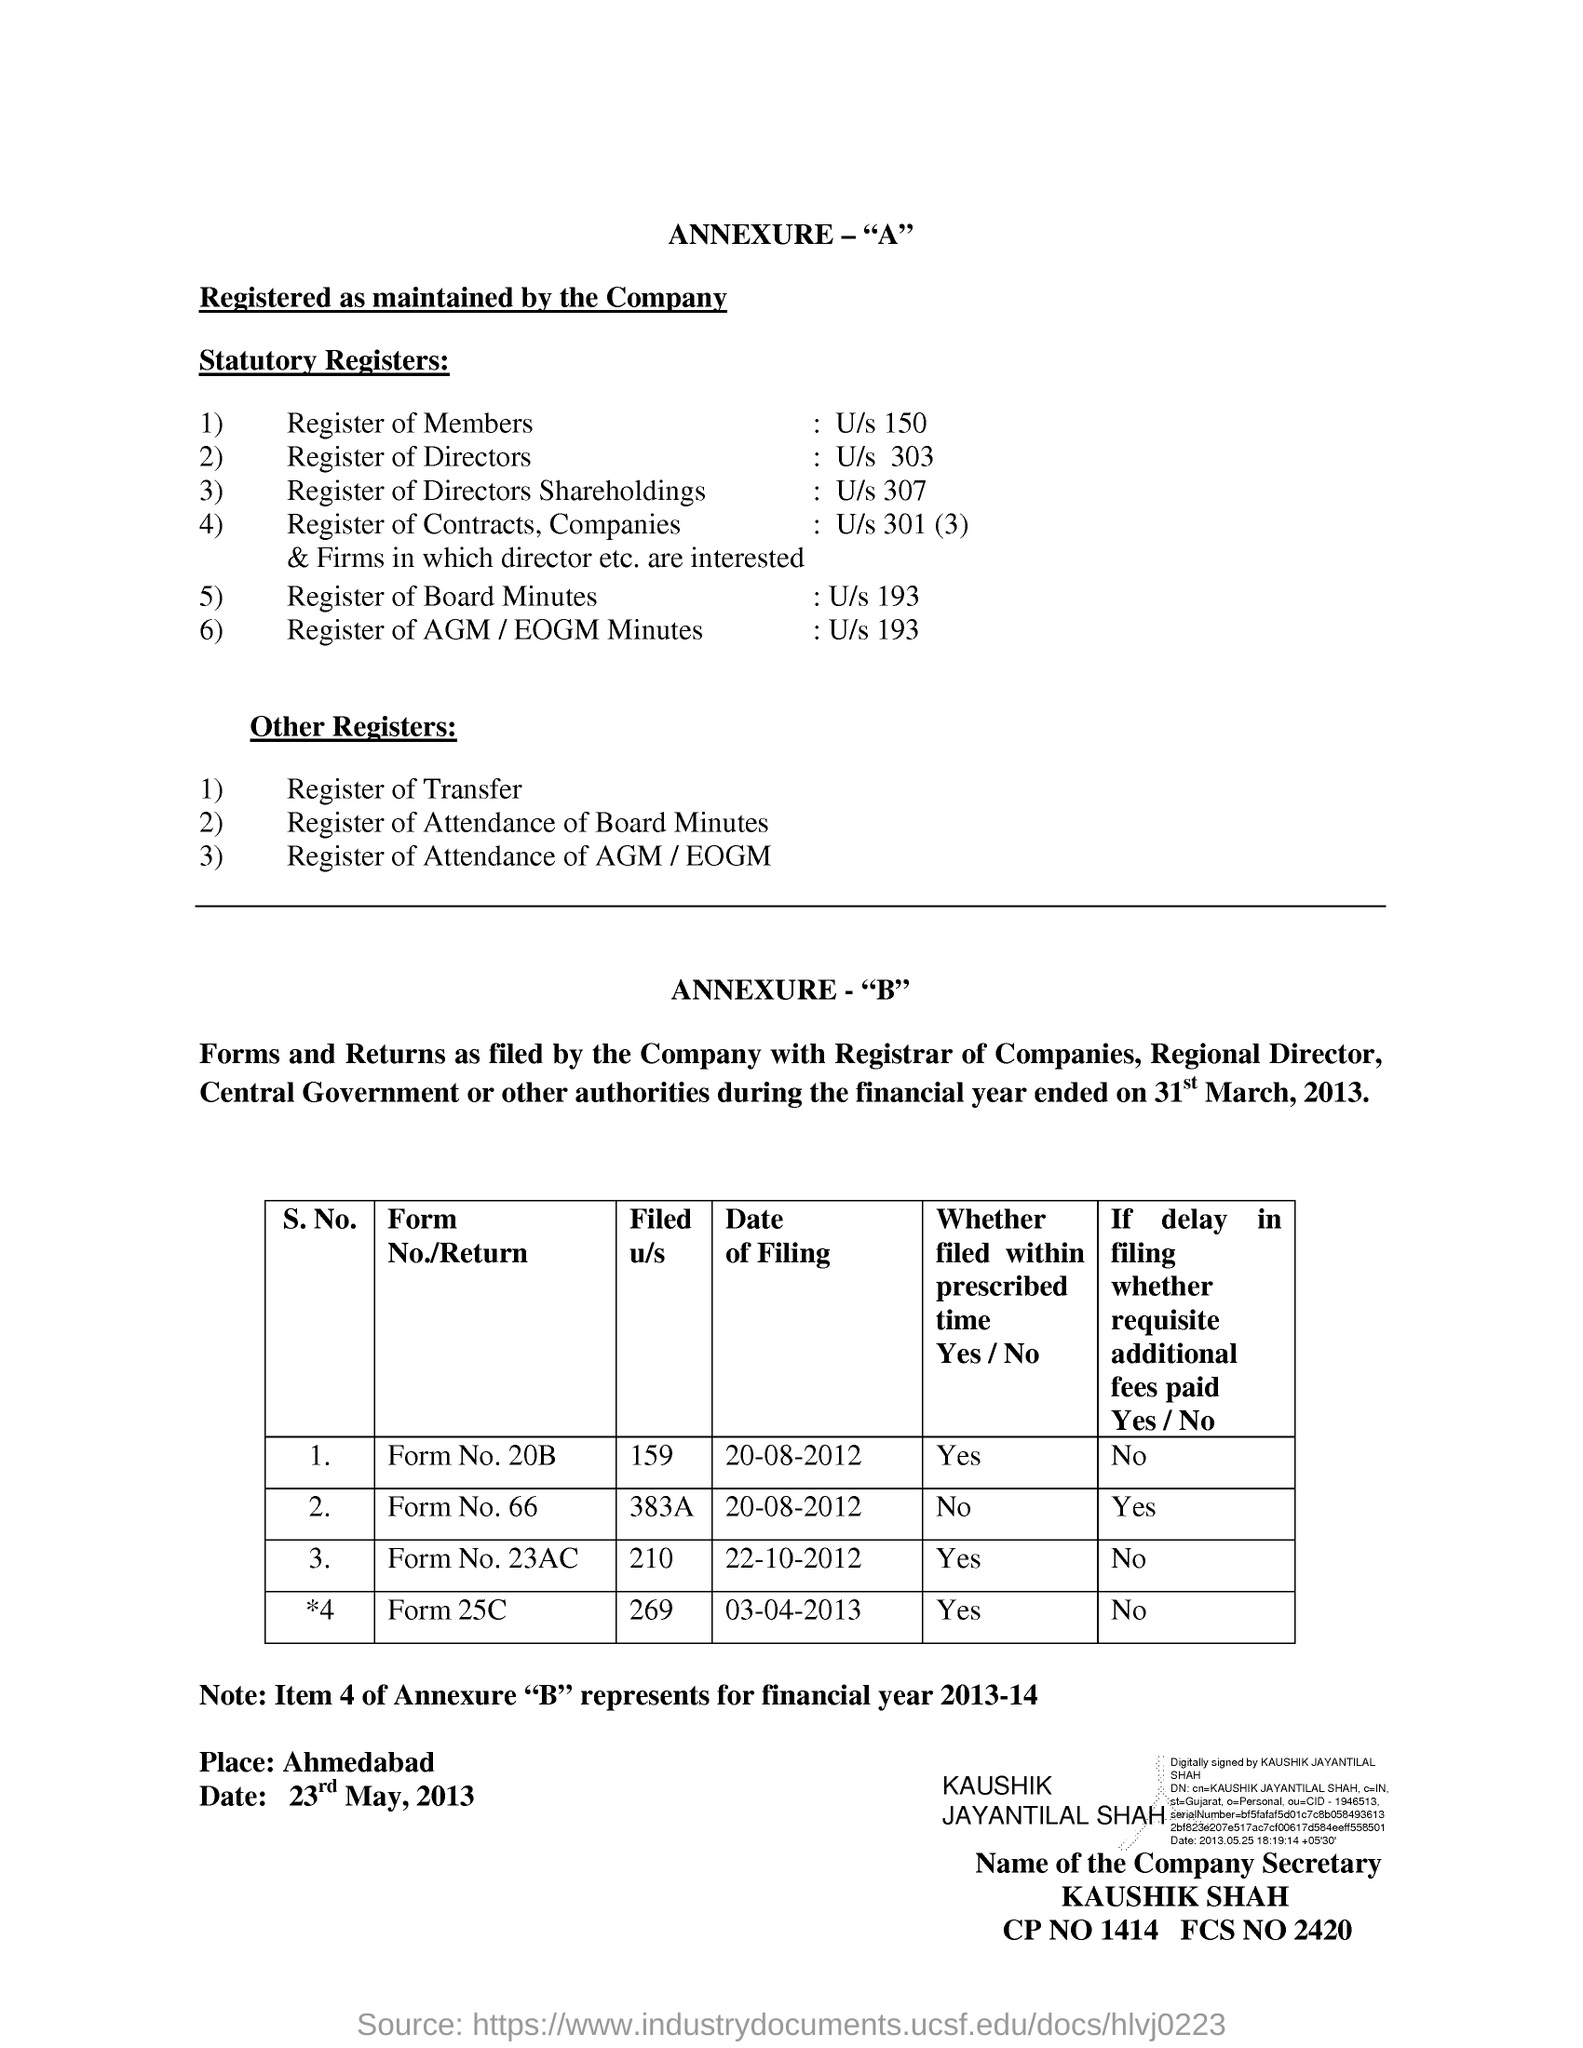Outline some significant characteristics in this image. Six statuary registers are maintained. In addition to the general-purpose registers maintained by the operating system, there are also a number of other registers that are specific to certain tasks or processes. 